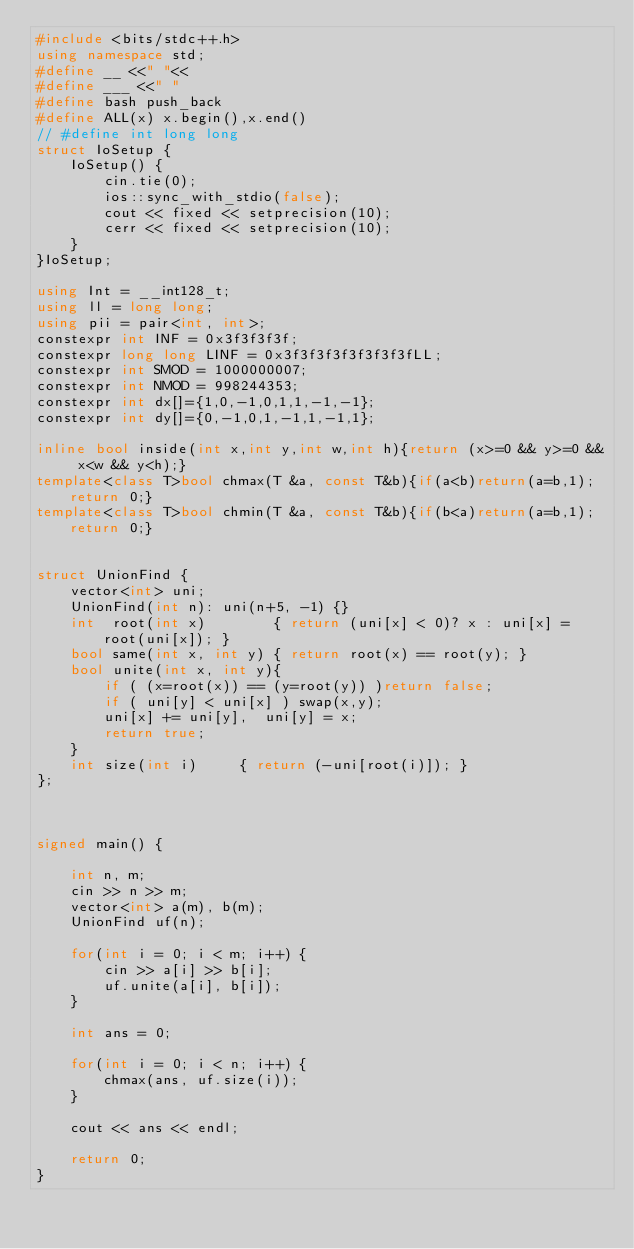Convert code to text. <code><loc_0><loc_0><loc_500><loc_500><_C++_>#include <bits/stdc++.h>
using namespace std;
#define __ <<" "<<
#define ___ <<" "
#define bash push_back
#define ALL(x) x.begin(),x.end()
// #define int long long
struct IoSetup {
    IoSetup() {
        cin.tie(0);
        ios::sync_with_stdio(false);
        cout << fixed << setprecision(10);
        cerr << fixed << setprecision(10);
    }
}IoSetup;

using Int = __int128_t;
using ll = long long;
using pii = pair<int, int>;
constexpr int INF = 0x3f3f3f3f;
constexpr long long LINF = 0x3f3f3f3f3f3f3f3fLL;
constexpr int SMOD = 1000000007;
constexpr int NMOD = 998244353;
constexpr int dx[]={1,0,-1,0,1,1,-1,-1};
constexpr int dy[]={0,-1,0,1,-1,1,-1,1};

inline bool inside(int x,int y,int w,int h){return (x>=0 && y>=0 && x<w && y<h);}
template<class T>bool chmax(T &a, const T&b){if(a<b)return(a=b,1);return 0;}
template<class T>bool chmin(T &a, const T&b){if(b<a)return(a=b,1);return 0;}


struct UnionFind {
    vector<int> uni;
    UnionFind(int n): uni(n+5, -1) {}
    int  root(int x)        { return (uni[x] < 0)? x : uni[x] = root(uni[x]); }
    bool same(int x, int y) { return root(x) == root(y); }
    bool unite(int x, int y){
        if ( (x=root(x)) == (y=root(y)) )return false;
        if ( uni[y] < uni[x] ) swap(x,y);
        uni[x] += uni[y],  uni[y] = x;
        return true;
    }
    int size(int i)     { return (-uni[root(i)]); }
};



signed main() {

    int n, m;
    cin >> n >> m;
    vector<int> a(m), b(m);
    UnionFind uf(n);

    for(int i = 0; i < m; i++) {
        cin >> a[i] >> b[i];
        uf.unite(a[i], b[i]);
    }

    int ans = 0;

    for(int i = 0; i < n; i++) {
        chmax(ans, uf.size(i));
    }

    cout << ans << endl;

    return 0;
}</code> 